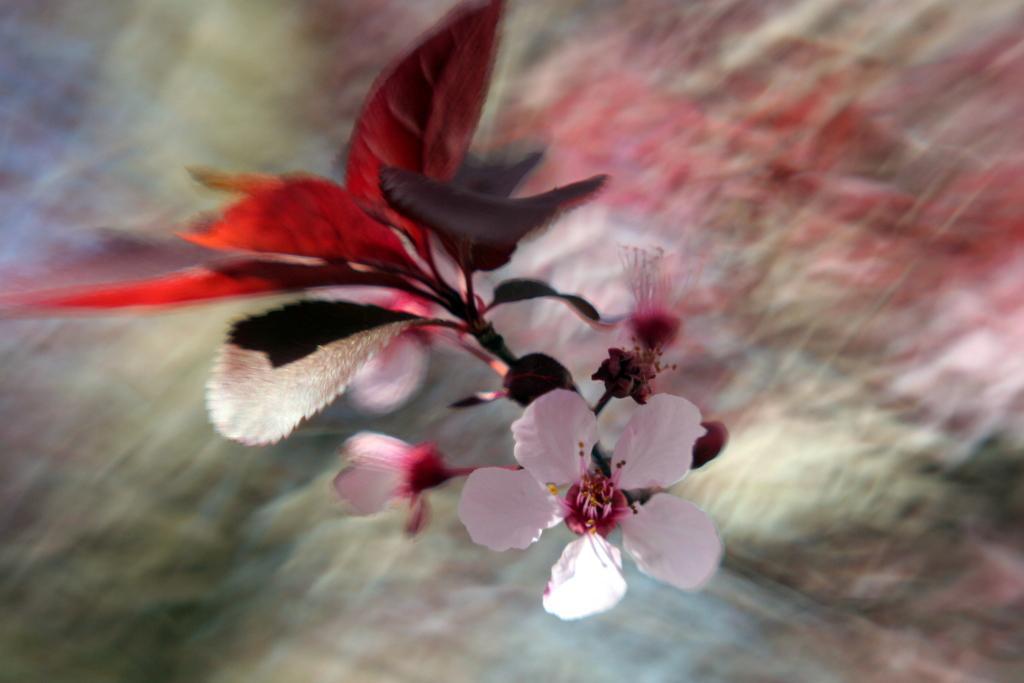Could you give a brief overview of what you see in this image? This is a plant with flower. 